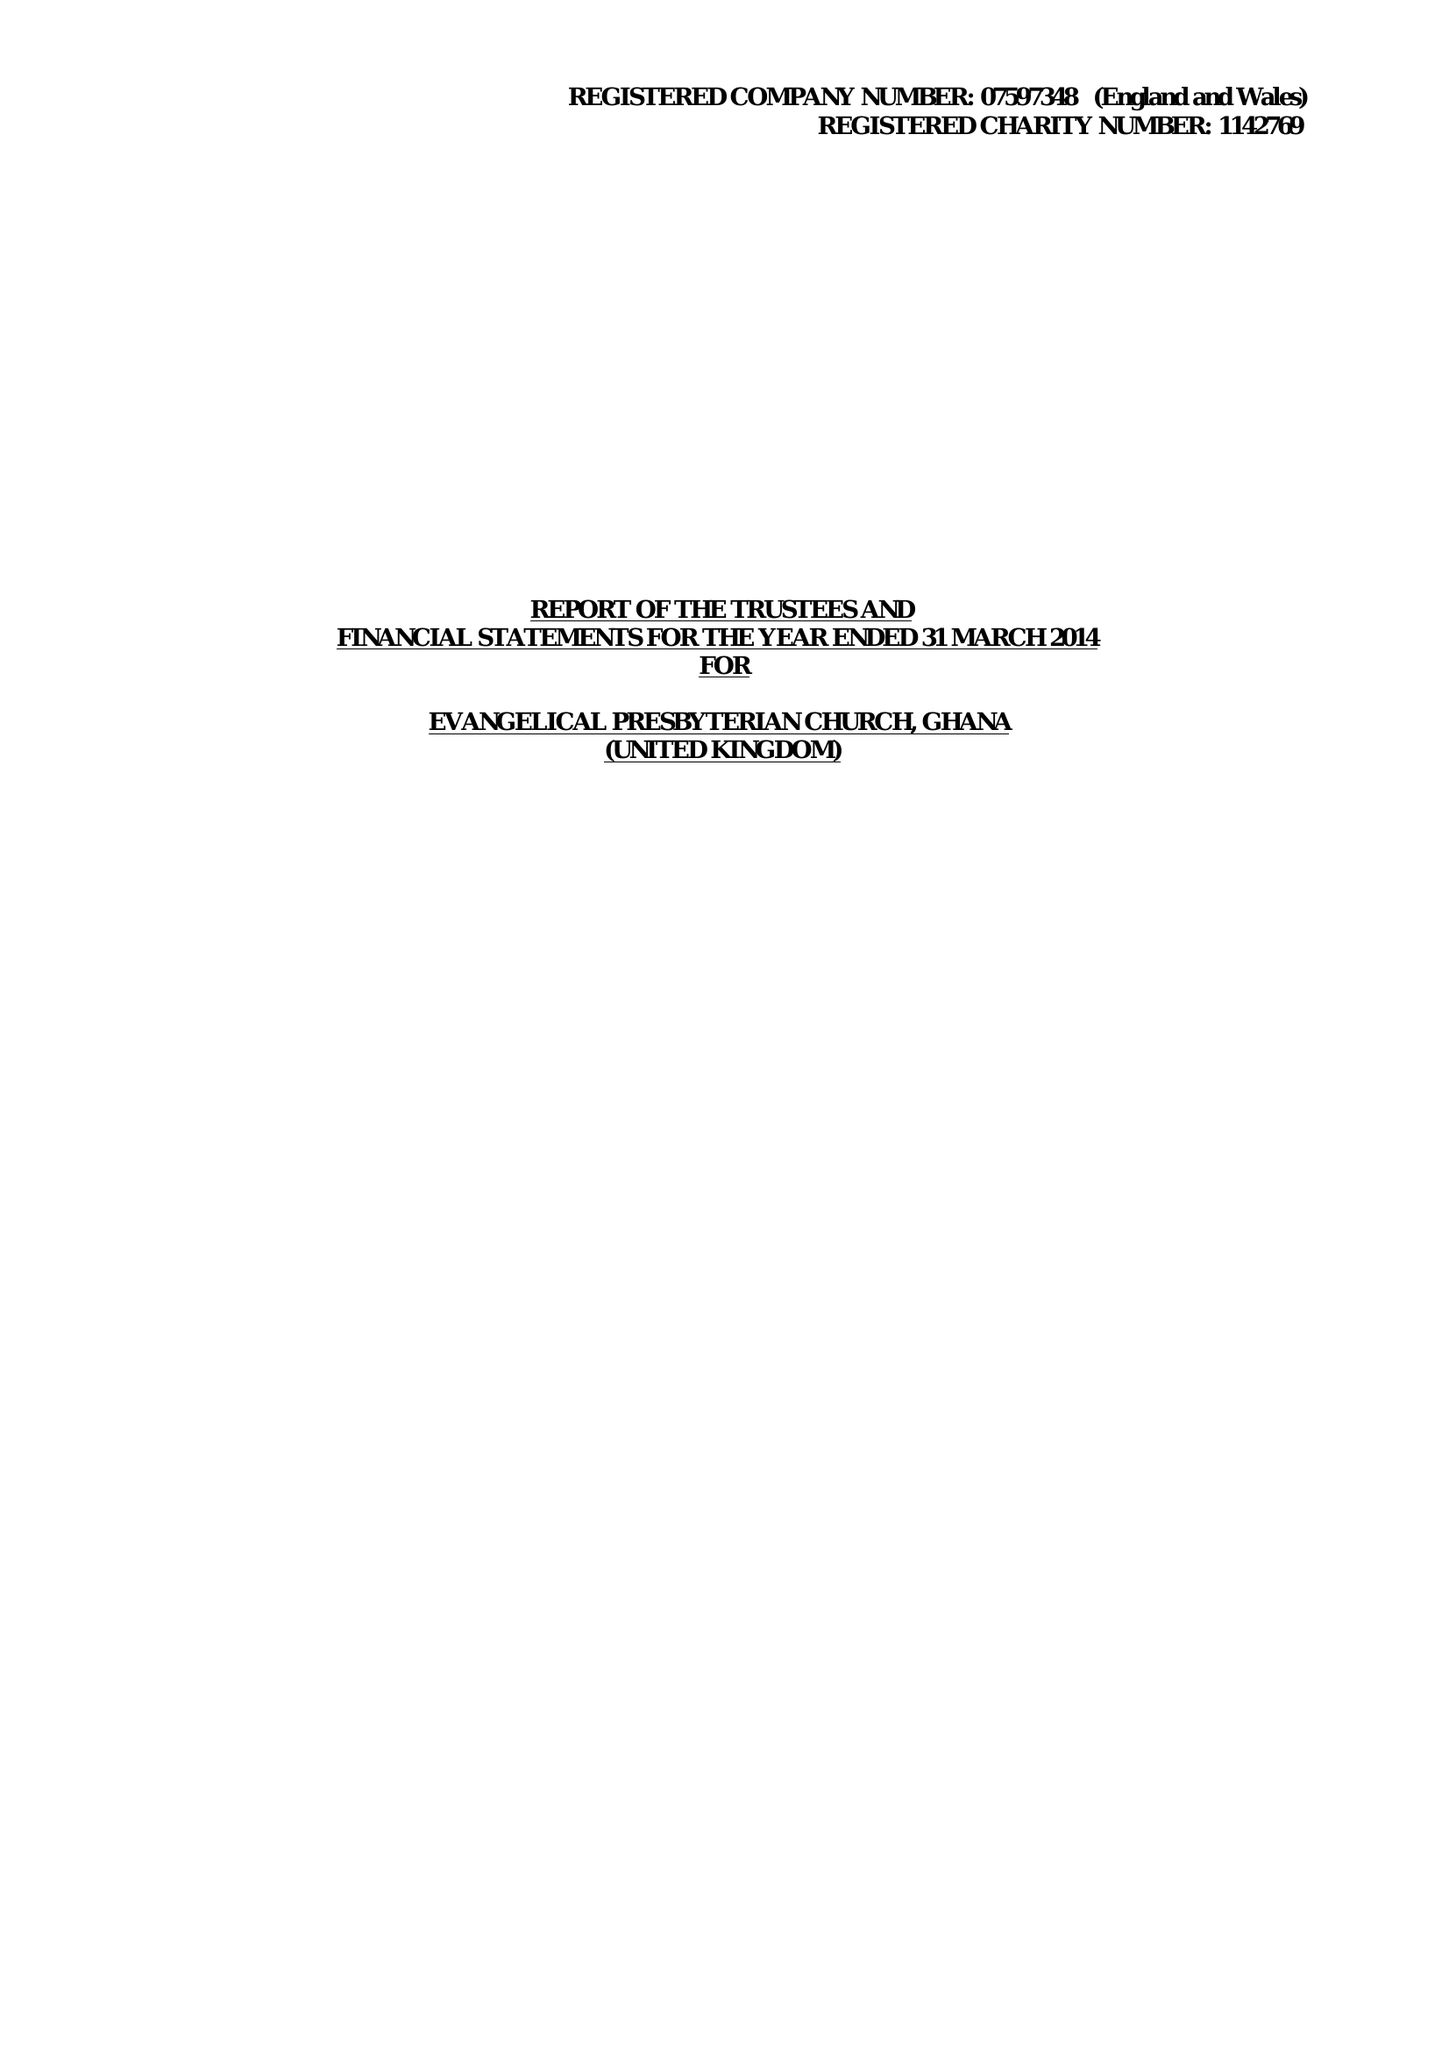What is the value for the address__street_line?
Answer the question using a single word or phrase. None 